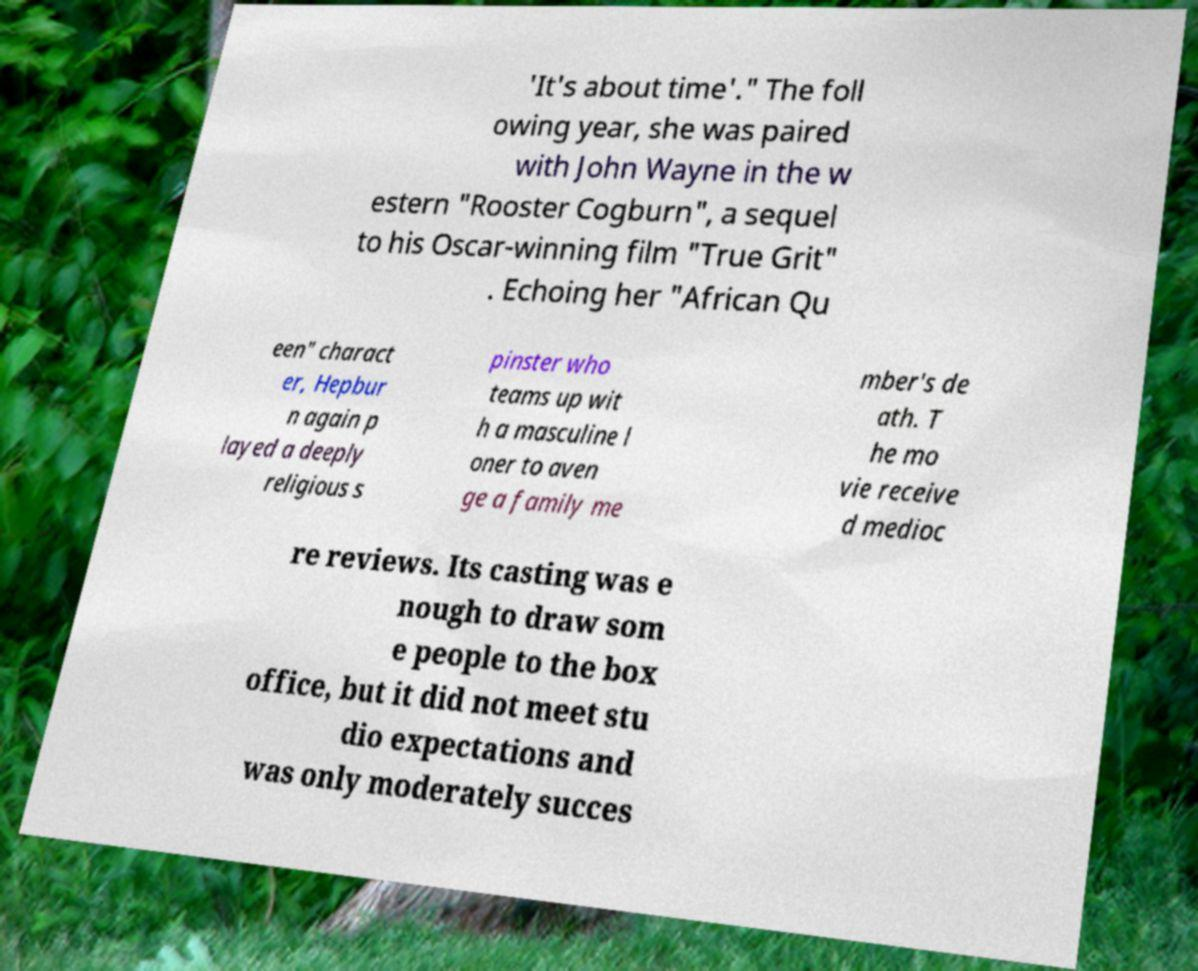What messages or text are displayed in this image? I need them in a readable, typed format. 'It's about time'." The foll owing year, she was paired with John Wayne in the w estern "Rooster Cogburn", a sequel to his Oscar-winning film "True Grit" . Echoing her "African Qu een" charact er, Hepbur n again p layed a deeply religious s pinster who teams up wit h a masculine l oner to aven ge a family me mber's de ath. T he mo vie receive d medioc re reviews. Its casting was e nough to draw som e people to the box office, but it did not meet stu dio expectations and was only moderately succes 